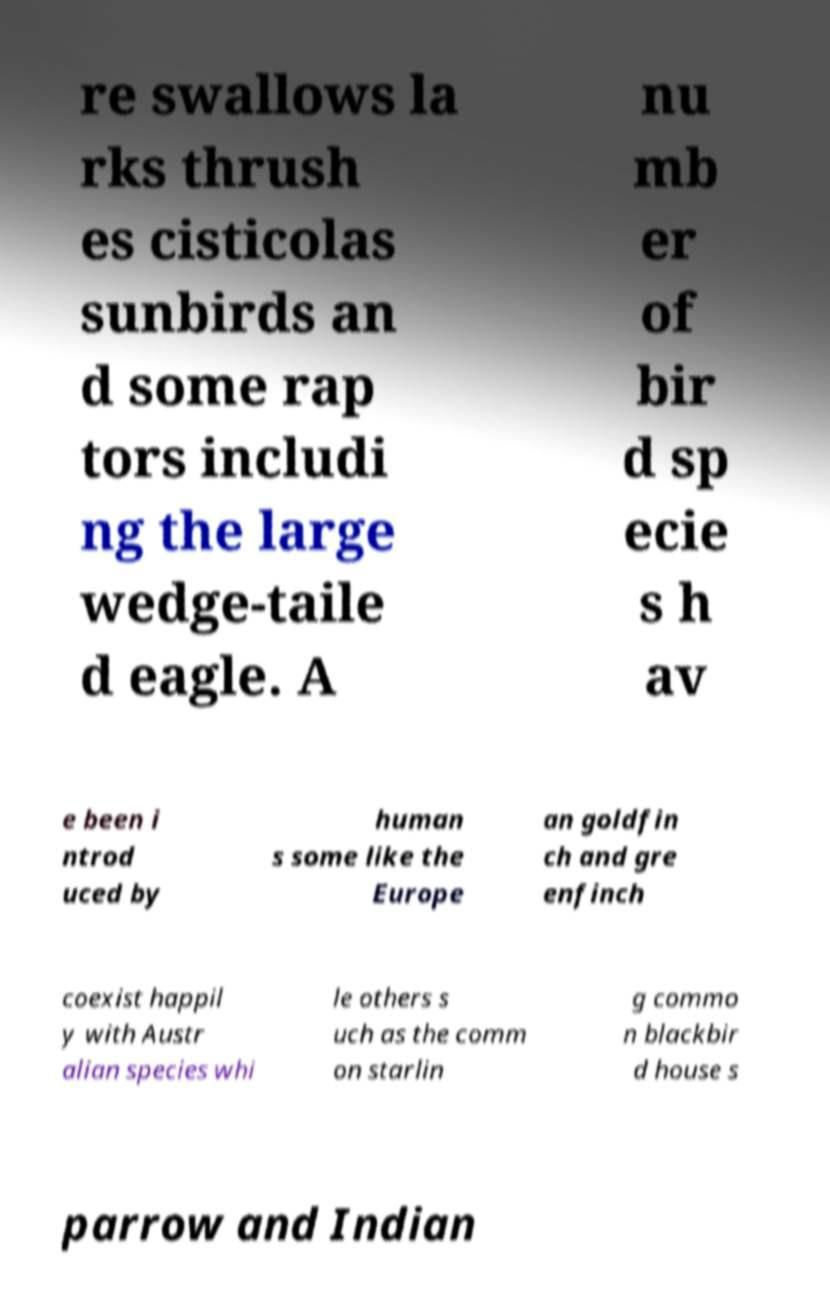I need the written content from this picture converted into text. Can you do that? re swallows la rks thrush es cisticolas sunbirds an d some rap tors includi ng the large wedge-taile d eagle. A nu mb er of bir d sp ecie s h av e been i ntrod uced by human s some like the Europe an goldfin ch and gre enfinch coexist happil y with Austr alian species whi le others s uch as the comm on starlin g commo n blackbir d house s parrow and Indian 